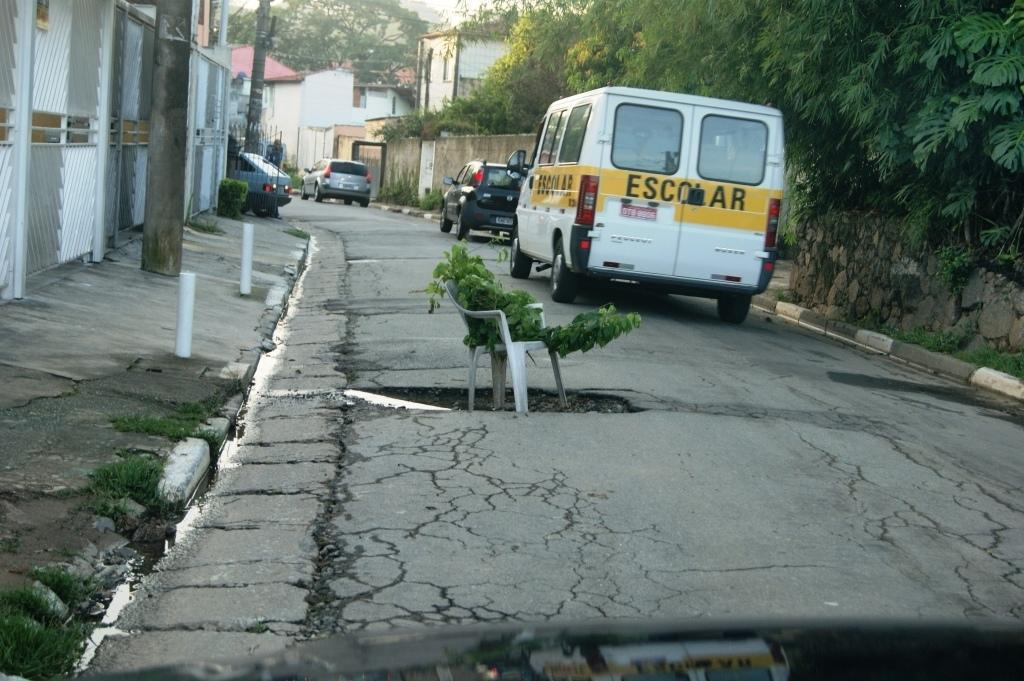What can be seen on the road in the image? There are vehicles on the road in the image. What is the chair in the image supporting? The chair in the image is supporting a branch of a tree. What are the poles and rods in the image used for? The poles and rods in the image are likely used for supporting structures or wires. What type of structures can be seen in the image? There are buildings in the image. What type of vegetation is present in the image? There are trees in the image. What type of government is depicted in the image? There is no depiction of a government in the image. What color is the pen used by the person in the image? There is no person or pen present in the image. 